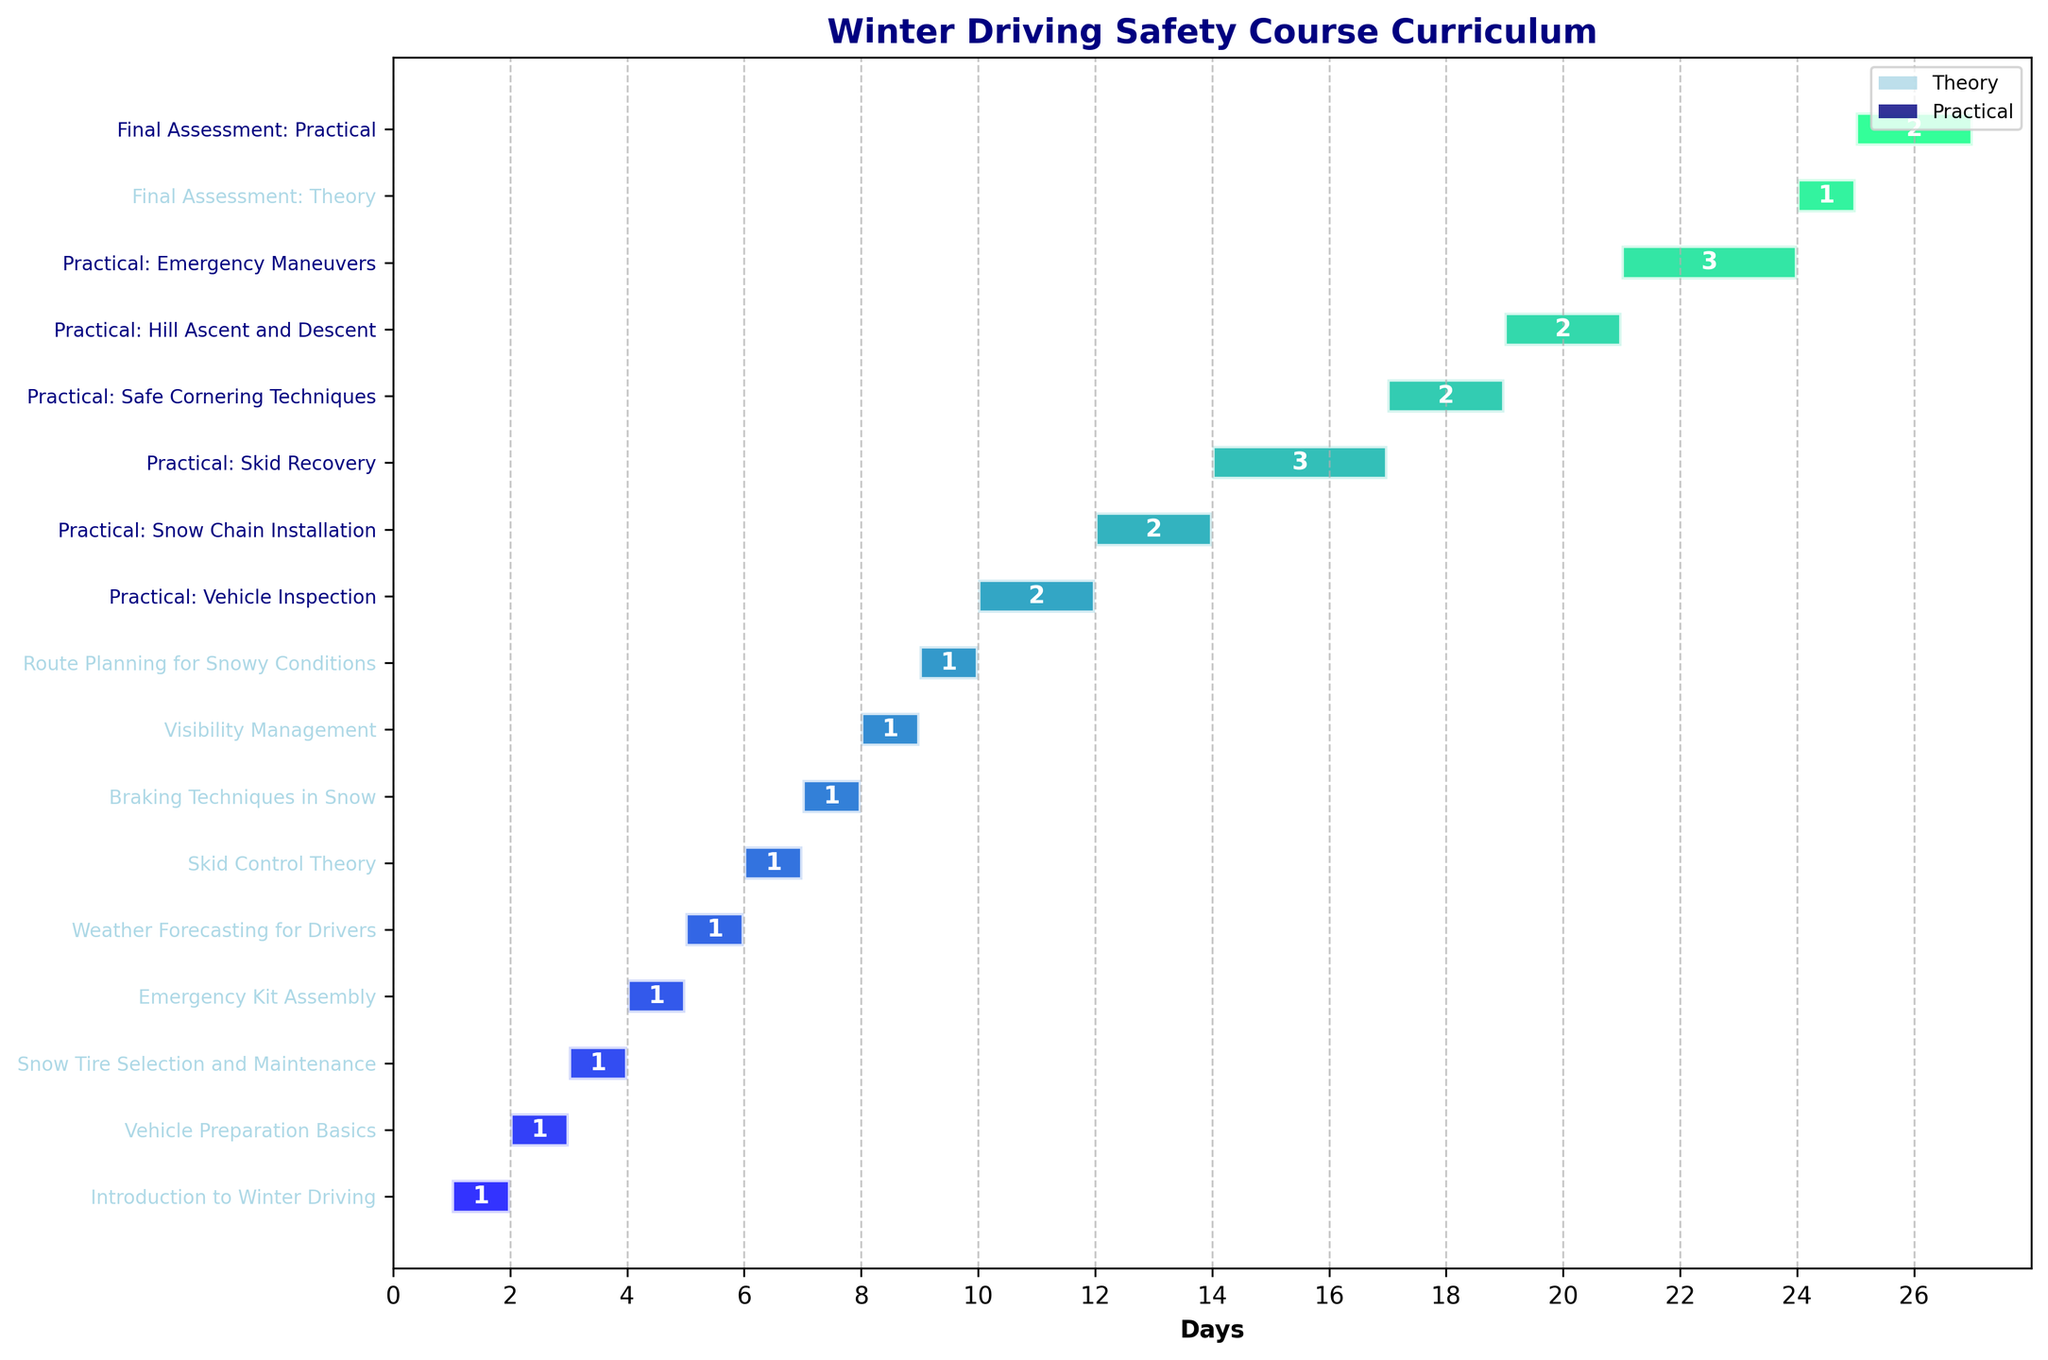What is the title of the Gantt Chart? The title of the Gantt Chart is usually placed at the top of the chart and is designed to provide a summary of the content being visualized. In this case, the title is "Winter Driving Safety Course Curriculum."
Answer: Winter Driving Safety Course Curriculum How long is the "Final Assessment: Theory" session? The duration of each task is indicated by the length of the horizontal bar and labeled with the number of days. The "Final Assessment: Theory" session has a duration of 1 day.
Answer: 1 day Which session has the longest duration? By examining the length of the horizontal bars and the duration labels, the "Practical: Skid Recovery" and "Practical: Emergency Maneuvers" sessions each have the longest duration of 3 days.
Answer: Practical: Skid Recovery and Practical: Emergency Maneuvers How many practical sessions are included in the course? The practical sessions are highlighted and color-coded (navy). By counting the number of such sessions, we find there are 7 practical sessions: "Practical: Vehicle Inspection," "Practical: Snow Chain Installation," "Practical: Skid Recovery," "Practical: Safe Cornering Techniques," "Practical: Hill Ascent and Descent," "Practical: Emergency Maneuvers," and "Final Assessment: Practical."
Answer: 7 sessions What is the total duration of all theory sessions combined? To find the total duration, add the number of days for each theory session: 1 (Introduction) + 1 (Vehicle Preparation Basics) + 1 (Snow Tire Selection) + 1 (Emergency Kit Assembly) + 1 (Weather Forecasting) + 1 (Skid Control Theory) + 1 (Braking Techniques) + 1 (Visibility Management) + 1 (Route Planning) + 1 (Final Assessment: Theory). This gives a total of 10 days.
Answer: 10 days What section is scheduled right after "Snow Tire Selection and Maintenance"? To determine the session following "Snow Tire Selection and Maintenance," check the chronological order in which tasks are listed. The next session is "Emergency Kit Assembly."
Answer: Emergency Kit Assembly How does the duration of "Skid Control Theory" compare to "Practical: Vehicle Inspection"? In the chart, "Skid Control Theory" lasts for 1 day, and "Practical: Vehicle Inspection" has a duration of 2 days. Therefore, "Practical: Vehicle Inspection" is longer by 1 day.
Answer: Practical: Vehicle Inspection is 1 day longer What is the total duration of the course? To find the total duration, look at the start and end points of the last task on the chart. The course starts on day 1 and ends on day 26, so the total duration is 26 days.
Answer: 26 days Which practical session occurs immediately before "Practical: Skid Recovery"? By following the sequence of practical sessions listed, "Practical: Snow Chain Installation" occurs immediately before "Practical: Skid Recovery."
Answer: Practical: Snow Chain Installation Identify the first session that involves both theory and practical elements? The first mixed session involved both theory and practical is "Final Assessment: Practical," because it includes practical assessment at the end of the course which comes after all the other theory sessions.
Answer: Final Assessment: Practical 